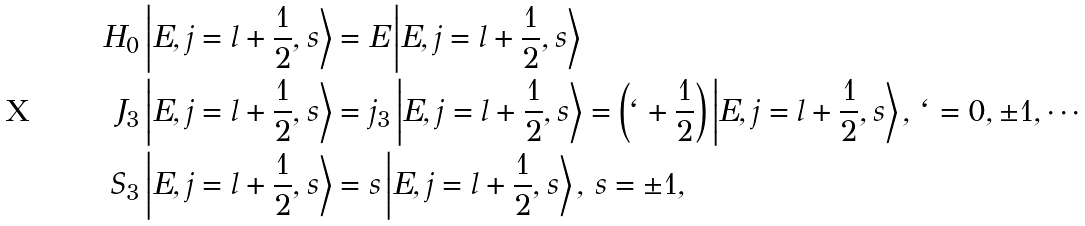Convert formula to latex. <formula><loc_0><loc_0><loc_500><loc_500>H _ { 0 } \left | E , j = l + \frac { 1 } { 2 } , s \right > & = E \left | E , j = l + \frac { 1 } { 2 } , s \right > \\ J _ { 3 } \left | E , j = l + \frac { 1 } { 2 } , s \right > & = j _ { 3 } \left | E , j = l + \frac { 1 } { 2 } , s \right > = \left ( { \ell + \frac { 1 } { 2 } } \right ) \left | E , j = l + \frac { 1 } { 2 } , s \right > , \, \ell = 0 , \pm 1 , \cdots \\ S _ { 3 } \left | E , j = l + \frac { 1 } { 2 } , s \right > & = s \left | E , j = l + \frac { 1 } { 2 } , s \right > , \, s = \pm 1 ,</formula> 